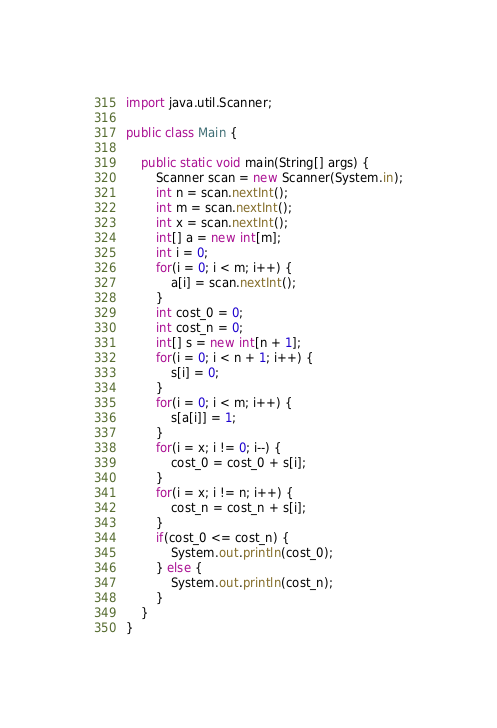Convert code to text. <code><loc_0><loc_0><loc_500><loc_500><_Java_>import java.util.Scanner;

public class Main {

	public static void main(String[] args) {
		Scanner scan = new Scanner(System.in);
		int n = scan.nextInt();
		int m = scan.nextInt();
		int x = scan.nextInt();
		int[] a = new int[m];
		int i = 0;
		for(i = 0; i < m; i++) {
			a[i] = scan.nextInt();
		}
		int cost_0 = 0;
		int cost_n = 0;
		int[] s = new int[n + 1];
		for(i = 0; i < n + 1; i++) {
			s[i] = 0;
		}
		for(i = 0; i < m; i++) {
			s[a[i]] = 1;
		}
		for(i = x; i != 0; i--) {
			cost_0 = cost_0 + s[i];
		}
		for(i = x; i != n; i++) {
			cost_n = cost_n + s[i];
		}
		if(cost_0 <= cost_n) {
			System.out.println(cost_0);
		} else {
			System.out.println(cost_n);
		}
	}
}</code> 